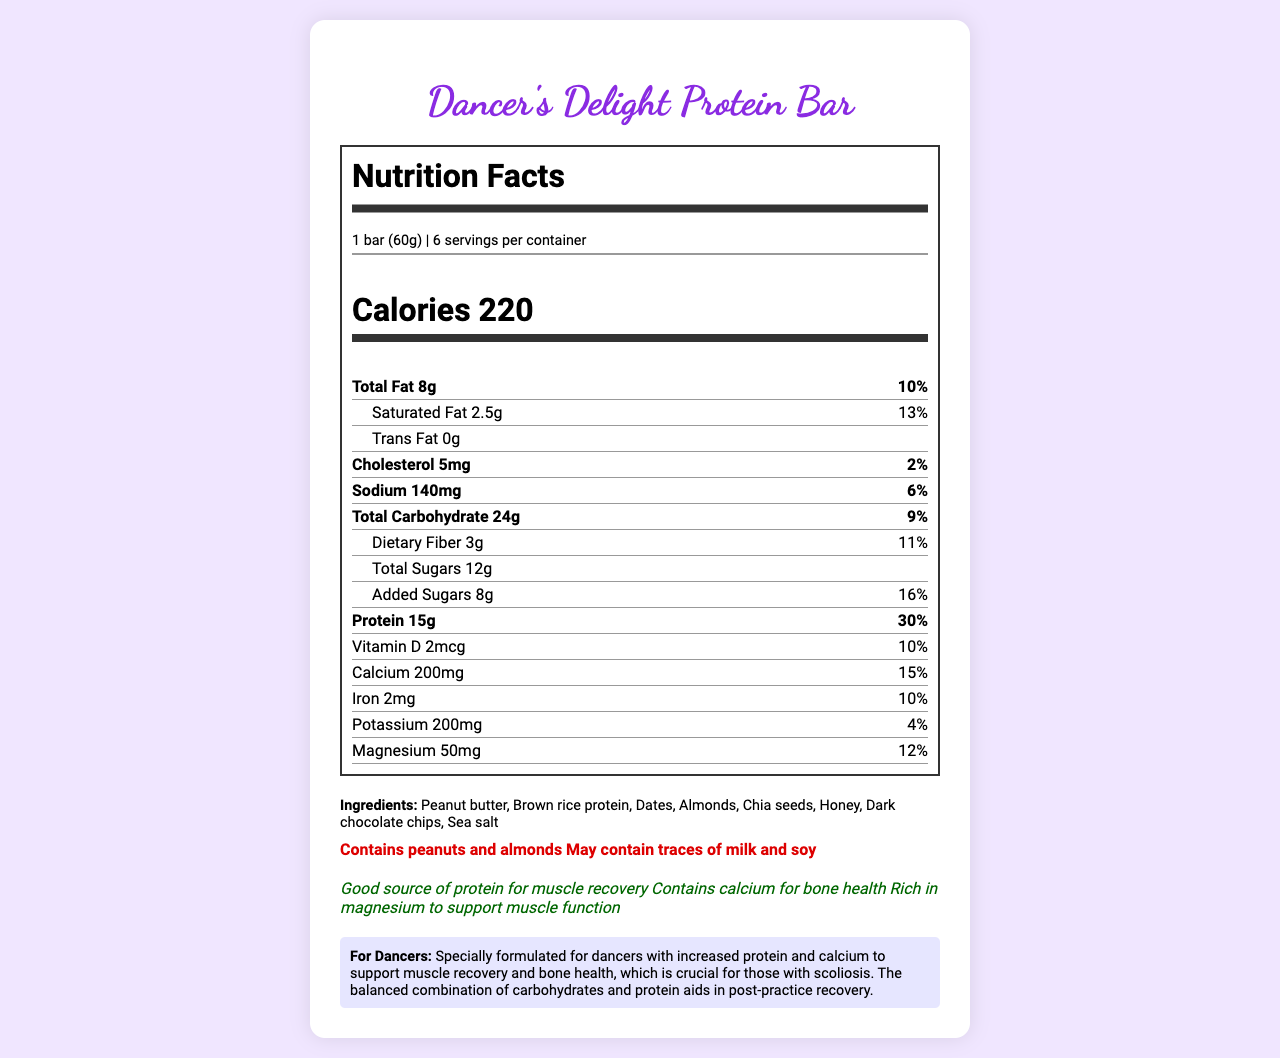What is the serving size of the Dancer's Delight Protein Bar? The serving size is explicitly mentioned as "1 bar (60g)" in the document.
Answer: 1 bar (60g) How many servings are there in one container? The document states there are 6 servings per container.
Answer: 6 What percentage of daily value of protein does one bar provide? The protein section shows that one bar provides 30% of the daily value of protein.
Answer: 30% How much calcium does one bar of the Dancer's Delight Protein Bar contain? The document lists the calcium content as 200mg.
Answer: 200mg What are the main ingredients of the Dancer's Delight Protein Bar? The ingredients list includes Peanut butter, Brown rice protein, Dates, Almonds, Chia seeds, Honey, Dark chocolate chips, and Sea salt.
Answer: Peanut butter, Brown rice protein, Dates, Almonds, Chia seeds, Honey, Dark chocolate chips, Sea salt How much total fat is in one bar? The total fat content is listed as 8g.
Answer: 8g How much added sugars are present in one serving? The amount of added sugars is specified as 8g.
Answer: 8g Which of the following allergens might the Dancer's Delight Protein Bar contain? A. Milk and soy B. Fish C. Gluten The document states that the bar may contain traces of milk and soy.
Answer: A. Milk and soy What is the primary health claim made about this product? A. Supports heart health B. Good source of protein for muscle recovery C. Low in calories D. Enhances mental focus The health claims section mentions that the bar is a good source of protein for muscle recovery.
Answer: B. Good source of protein for muscle recovery Is the Dancer's Delight Protein Bar suitable for people with peanut allergies? The allergen information indicates that the product contains peanuts.
Answer: No Summarize the main idea of the document. The document focuses on presenting detailed nutrition information and health benefits of the Dancer's Delight Protein Bar, tailored for dancers needing muscle recovery and bone health support. It highlights the protein content, essential minerals, and safety information regarding allergens.
Answer: The Dancer's Delight Protein Bar is a protein-packed snack designed to aid muscle recovery, especially for dancers with scoliosis. It contains a balanced mix of protein, carbohydrates, and essential minerals like calcium and magnesium. The document details its nutrition facts, ingredients, allergens, health claims, and dancer-specific benefits. What is the exact percentage of daily value for sodium in the Dancer's Delight Protein Bar? The sodium content provides 6% of the daily value.
Answer: 6% Does the product contain any dietary fiber? If so, how much? The document states that the product contains 3g of dietary fiber, which is 11% of the daily value.
Answer: Yes, 3g What is the manufacturer's name of the Dancer's Delight Protein Bar? The manufacturer is listed as Flex Fuel Nutrition, Inc.
Answer: Flex Fuel Nutrition, Inc. What is the total amount of sugars (including added sugars) in one bar? The total sugars amount, including added sugars, is 12g as stated in the document.
Answer: 12g How much Vitamin D does one bar provide? The Vitamin D content is listed as 2mcg.
Answer: 2mcg How long can the Dancer's Delight Protein Bar be stored after opening? The storage instructions specify that the product should be consumed within 7 days of opening.
Answer: 7 days How many grams is one serving of the Dancer's Delight Protein Bar? A. 50g B. 60g C. 70g D. 80g The serving size is explicitly mentioned as "1 bar (60g)" in the document.
Answer: B. 60g What are the potential benefits of this protein bar specifically for dancers with scoliosis? The dancer-specific information details that the bar is formulated with increased protein and calcium, benefiting muscle recovery and bone health, which is particularly crucial for dancers with scoliosis.
Answer: Increased protein and calcium to support muscle recovery and bone health How much cholesterol does one bar contain? The cholesterol content is listed as 5mg.
Answer: 5mg What is the total number of vitamins and minerals listed in the document? The vitamins and minerals listed are Vitamin D, Calcium, Iron, Potassium, and Magnesium.
Answer: 5 How much protein would you consume if you ate two bars? One bar contains 15g of protein, so two bars contain 30g total.
Answer: 30g Does the Dancer's Delight Protein Bar contain gluten? The document does not provide information on whether the product contains gluten or not.
Answer: Cannot be determined 